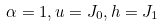<formula> <loc_0><loc_0><loc_500><loc_500>\alpha = 1 , u = J _ { 0 } , h = J _ { 1 }</formula> 